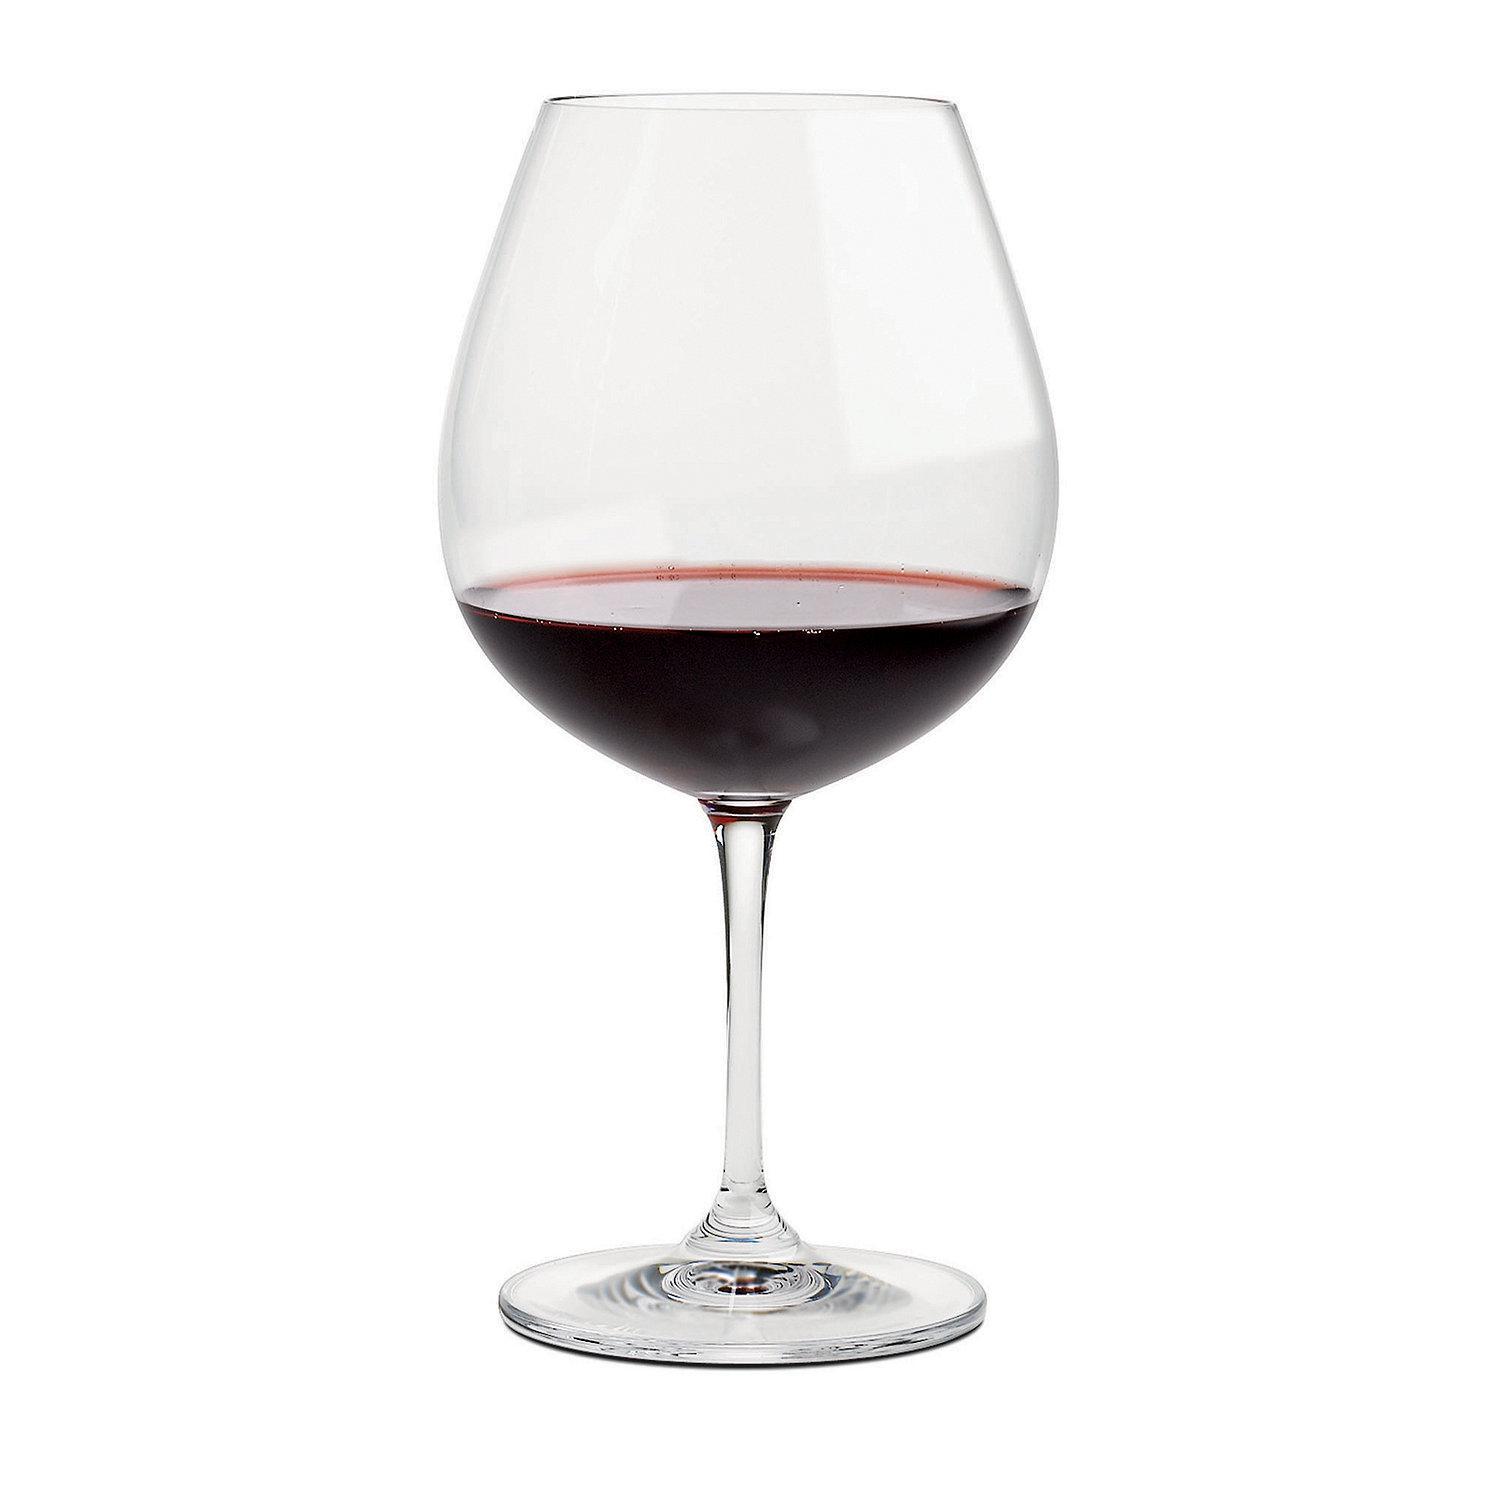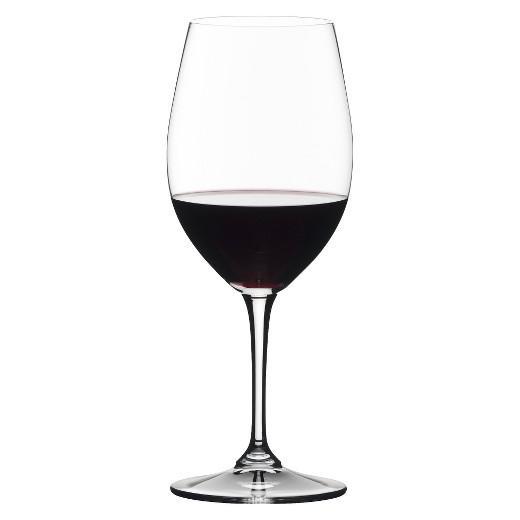The first image is the image on the left, the second image is the image on the right. Evaluate the accuracy of this statement regarding the images: "Wine is pouring into the glass in the image on the right.". Is it true? Answer yes or no. No. The first image is the image on the left, the second image is the image on the right. Examine the images to the left and right. Is the description "Red wine is pouring into a glass, creating a splash inside the glass." accurate? Answer yes or no. No. 